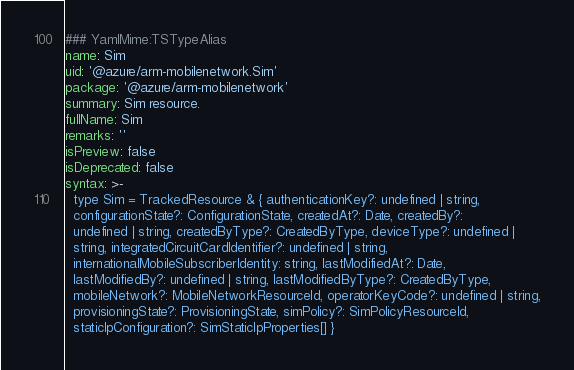Convert code to text. <code><loc_0><loc_0><loc_500><loc_500><_YAML_>### YamlMime:TSTypeAlias
name: Sim
uid: '@azure/arm-mobilenetwork.Sim'
package: '@azure/arm-mobilenetwork'
summary: Sim resource.
fullName: Sim
remarks: ''
isPreview: false
isDeprecated: false
syntax: >-
  type Sim = TrackedResource & { authenticationKey?: undefined | string,
  configurationState?: ConfigurationState, createdAt?: Date, createdBy?:
  undefined | string, createdByType?: CreatedByType, deviceType?: undefined |
  string, integratedCircuitCardIdentifier?: undefined | string,
  internationalMobileSubscriberIdentity: string, lastModifiedAt?: Date,
  lastModifiedBy?: undefined | string, lastModifiedByType?: CreatedByType,
  mobileNetwork?: MobileNetworkResourceId, operatorKeyCode?: undefined | string,
  provisioningState?: ProvisioningState, simPolicy?: SimPolicyResourceId,
  staticIpConfiguration?: SimStaticIpProperties[] }
</code> 